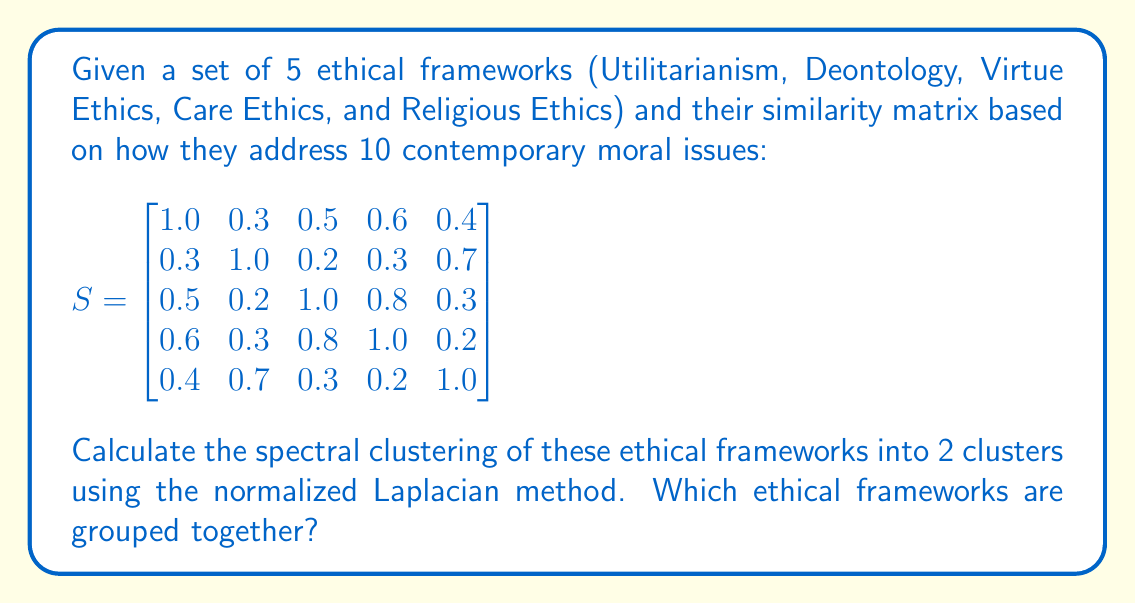Solve this math problem. To perform spectral clustering using the normalized Laplacian method:

1. Compute the degree matrix $D$:
   $$D = \begin{bmatrix}
   2.8 & 0 & 0 & 0 & 0 \\
   0 & 2.5 & 0 & 0 & 0 \\
   0 & 0 & 2.8 & 0 & 0 \\
   0 & 0 & 0 & 2.9 & 0 \\
   0 & 0 & 0 & 0 & 2.6
   \end{bmatrix}$$

2. Calculate the normalized Laplacian $L_{sym} = I - D^{-1/2}SD^{-1/2}$:
   $$L_{sym} = I - \begin{bmatrix}
   0.598 & 0.114 & 0.178 & 0.210 & 0.148 \\
   0.114 & 0.632 & 0.075 & 0.111 & 0.274 \\
   0.178 & 0.075 & 0.598 & 0.280 & 0.111 \\
   0.210 & 0.111 & 0.280 & 0.590 & 0.074 \\
   0.148 & 0.274 & 0.111 & 0.074 & 0.620
   \end{bmatrix}$$

3. Compute eigenvalues and eigenvectors of $L_{sym}$. The two smallest non-zero eigenvalues are approximately 0.2018 and 0.3982.

4. Use the corresponding eigenvectors to form the matrix $U \in \mathbb{R}^{n \times k}$:
   $$U \approx \begin{bmatrix}
   -0.3964 & -0.5477 \\
   0.6745 & -0.1909 \\
   -0.3964 & 0.4477 \\
   -0.3374 & 0.6386 \\
   0.3374 & -0.2386
   \end{bmatrix}$$

5. Normalize the rows of $U$ to get $T$:
   $$T \approx \begin{bmatrix}
   -0.5865 & -0.8100 \\
   0.9622 & -0.2724 \\
   -0.6628 & 0.7488 \\
   -0.4671 & 0.8842 \\
   0.8165 & -0.5774
   \end{bmatrix}$$

6. Cluster the rows of $T$ using k-means (k=2).

The resulting clusters are:
Cluster 1: Utilitarianism, Virtue Ethics, Care Ethics
Cluster 2: Deontology, Religious Ethics
Answer: Cluster 1: Utilitarianism, Virtue Ethics, Care Ethics
Cluster 2: Deontology, Religious Ethics 